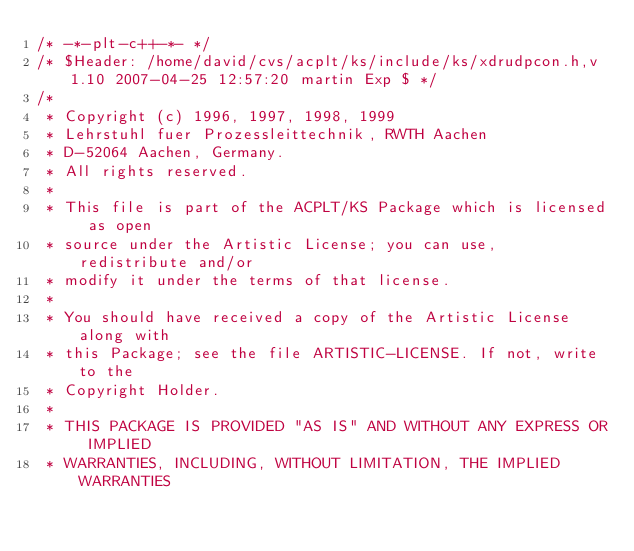Convert code to text. <code><loc_0><loc_0><loc_500><loc_500><_C_>/* -*-plt-c++-*- */
/* $Header: /home/david/cvs/acplt/ks/include/ks/xdrudpcon.h,v 1.10 2007-04-25 12:57:20 martin Exp $ */
/*
 * Copyright (c) 1996, 1997, 1998, 1999
 * Lehrstuhl fuer Prozessleittechnik, RWTH Aachen
 * D-52064 Aachen, Germany.
 * All rights reserved.
 *
 * This file is part of the ACPLT/KS Package which is licensed as open
 * source under the Artistic License; you can use, redistribute and/or
 * modify it under the terms of that license.
 *
 * You should have received a copy of the Artistic License along with
 * this Package; see the file ARTISTIC-LICENSE. If not, write to the
 * Copyright Holder.
 *
 * THIS PACKAGE IS PROVIDED "AS IS" AND WITHOUT ANY EXPRESS OR IMPLIED
 * WARRANTIES, INCLUDING, WITHOUT LIMITATION, THE IMPLIED WARRANTIES</code> 